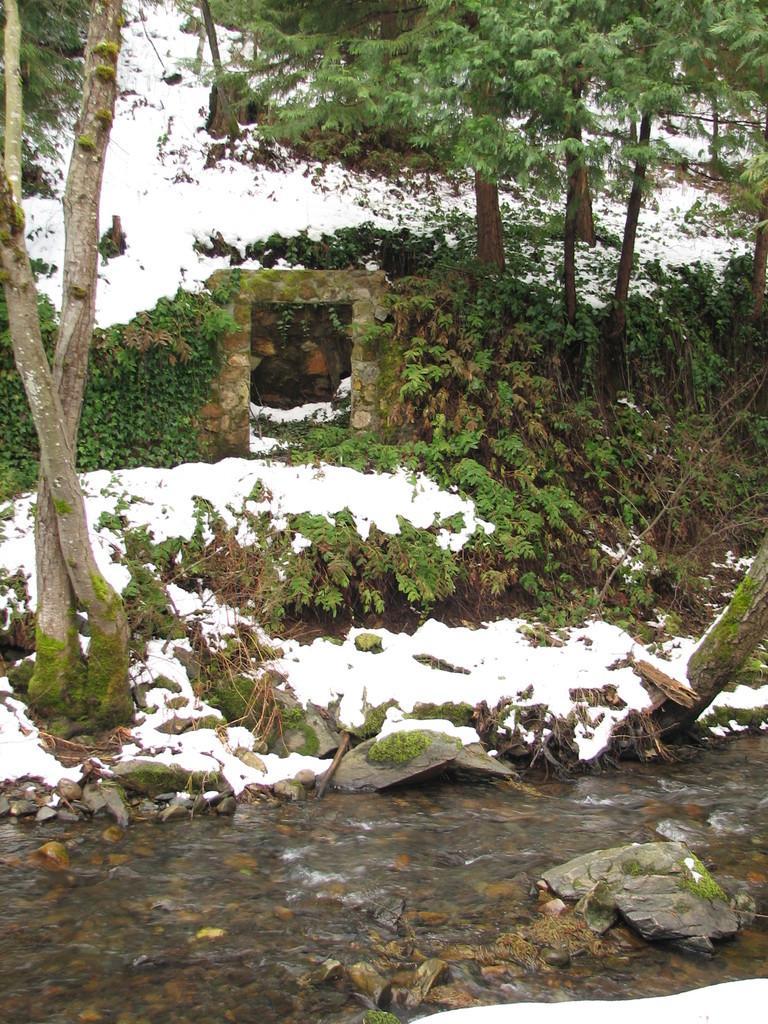In one or two sentences, can you explain what this image depicts? At the bottom of the image there is water with stones in it. Behind the water on the ground there is snow and also there are plants and grass on the ground. In the background there is a small stone arch and also to that arch there are creepers. There are trees and on the ground there is snow. 